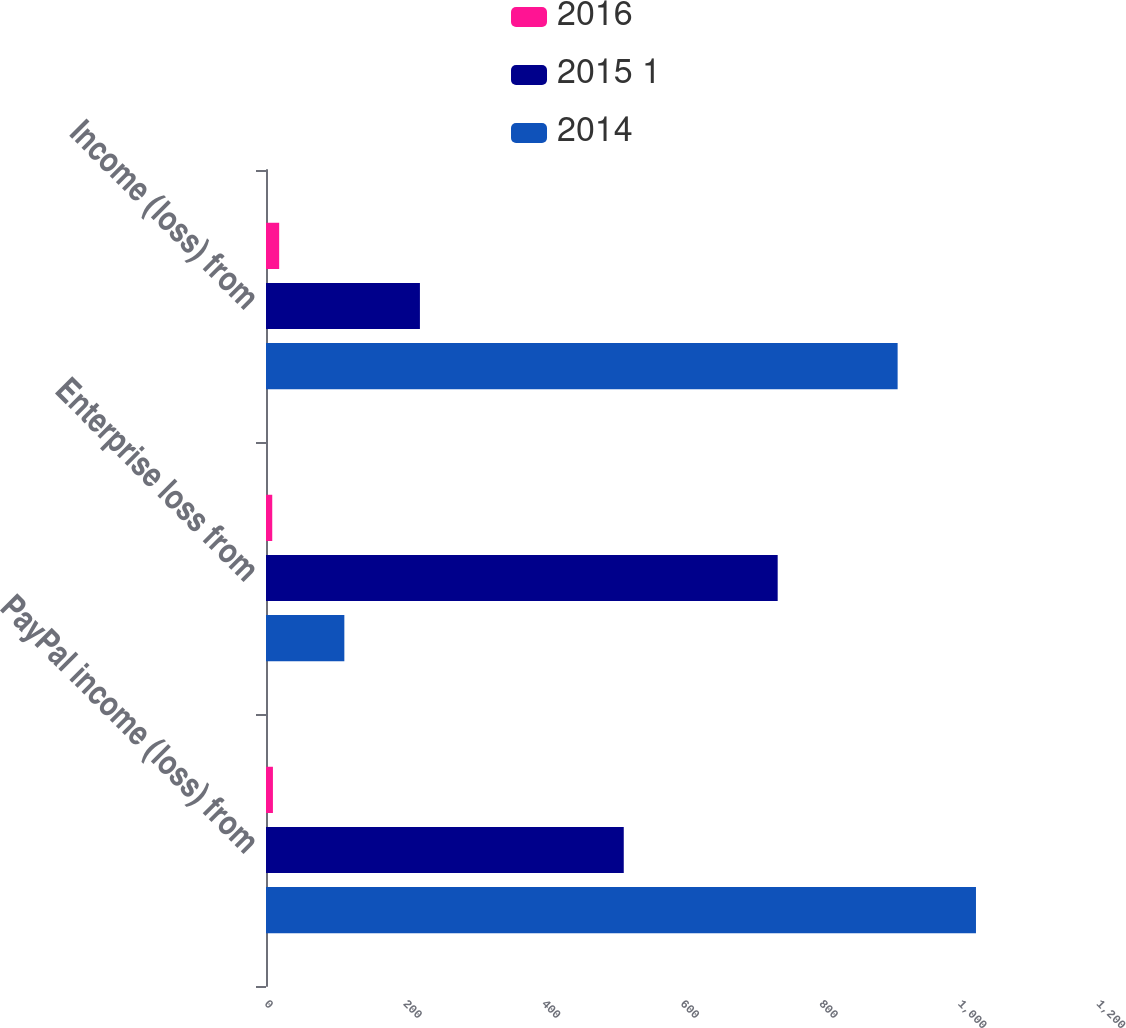Convert chart to OTSL. <chart><loc_0><loc_0><loc_500><loc_500><stacked_bar_chart><ecel><fcel>PayPal income (loss) from<fcel>Enterprise loss from<fcel>Income (loss) from<nl><fcel>2016<fcel>10<fcel>9<fcel>19<nl><fcel>2015 1<fcel>516<fcel>738<fcel>222<nl><fcel>2014<fcel>1024<fcel>113<fcel>911<nl></chart> 